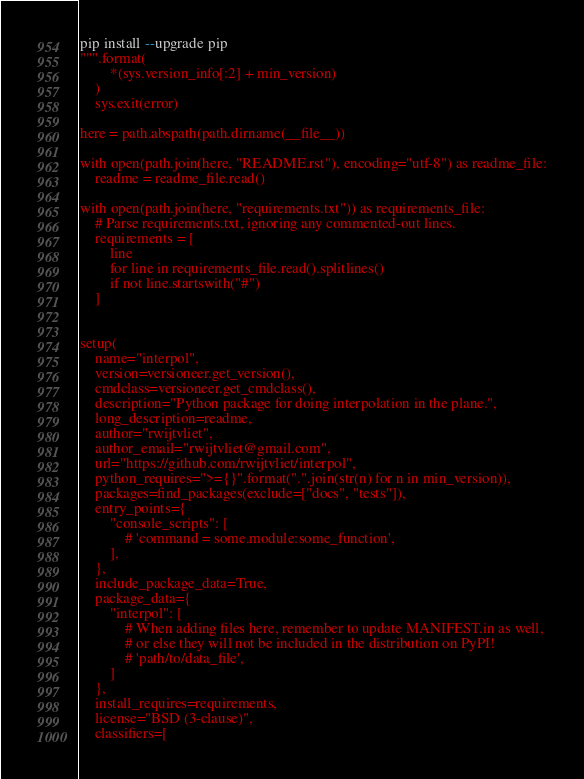Convert code to text. <code><loc_0><loc_0><loc_500><loc_500><_Python_>pip install --upgrade pip
""".format(
        *(sys.version_info[:2] + min_version)
    )
    sys.exit(error)

here = path.abspath(path.dirname(__file__))

with open(path.join(here, "README.rst"), encoding="utf-8") as readme_file:
    readme = readme_file.read()

with open(path.join(here, "requirements.txt")) as requirements_file:
    # Parse requirements.txt, ignoring any commented-out lines.
    requirements = [
        line
        for line in requirements_file.read().splitlines()
        if not line.startswith("#")
    ]


setup(
    name="interpol",
    version=versioneer.get_version(),
    cmdclass=versioneer.get_cmdclass(),
    description="Python package for doing interpolation in the plane.",
    long_description=readme,
    author="rwijtvliet",
    author_email="rwijtvliet@gmail.com",
    url="https://github.com/rwijtvliet/interpol",
    python_requires=">={}".format(".".join(str(n) for n in min_version)),
    packages=find_packages(exclude=["docs", "tests"]),
    entry_points={
        "console_scripts": [
            # 'command = some.module:some_function',
        ],
    },
    include_package_data=True,
    package_data={
        "interpol": [
            # When adding files here, remember to update MANIFEST.in as well,
            # or else they will not be included in the distribution on PyPI!
            # 'path/to/data_file',
        ]
    },
    install_requires=requirements,
    license="BSD (3-clause)",
    classifiers=[</code> 